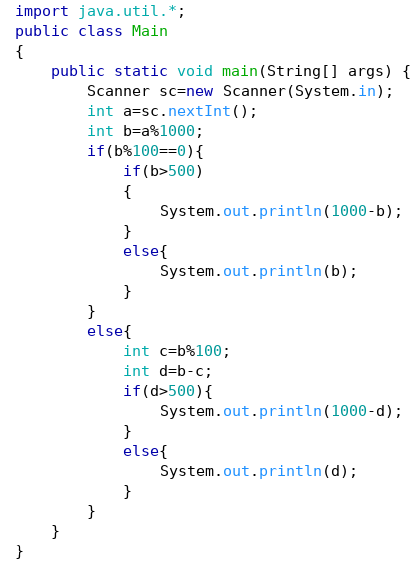Convert code to text. <code><loc_0><loc_0><loc_500><loc_500><_Java_>import java.util.*;
public class Main
{
	public static void main(String[] args) {
	    Scanner sc=new Scanner(System.in);
		int a=sc.nextInt();
		int b=a%1000;
		if(b%100==0){
		    if(b>500)
		    {
		        System.out.println(1000-b);
		    }
		    else{
		        System.out.println(b);
		    }
		}
		else{
		    int c=b%100;
		    int d=b-c;
		    if(d>500){
		        System.out.println(1000-d);
		    }
		    else{
		        System.out.println(d);
		    }
		}
	}
}</code> 